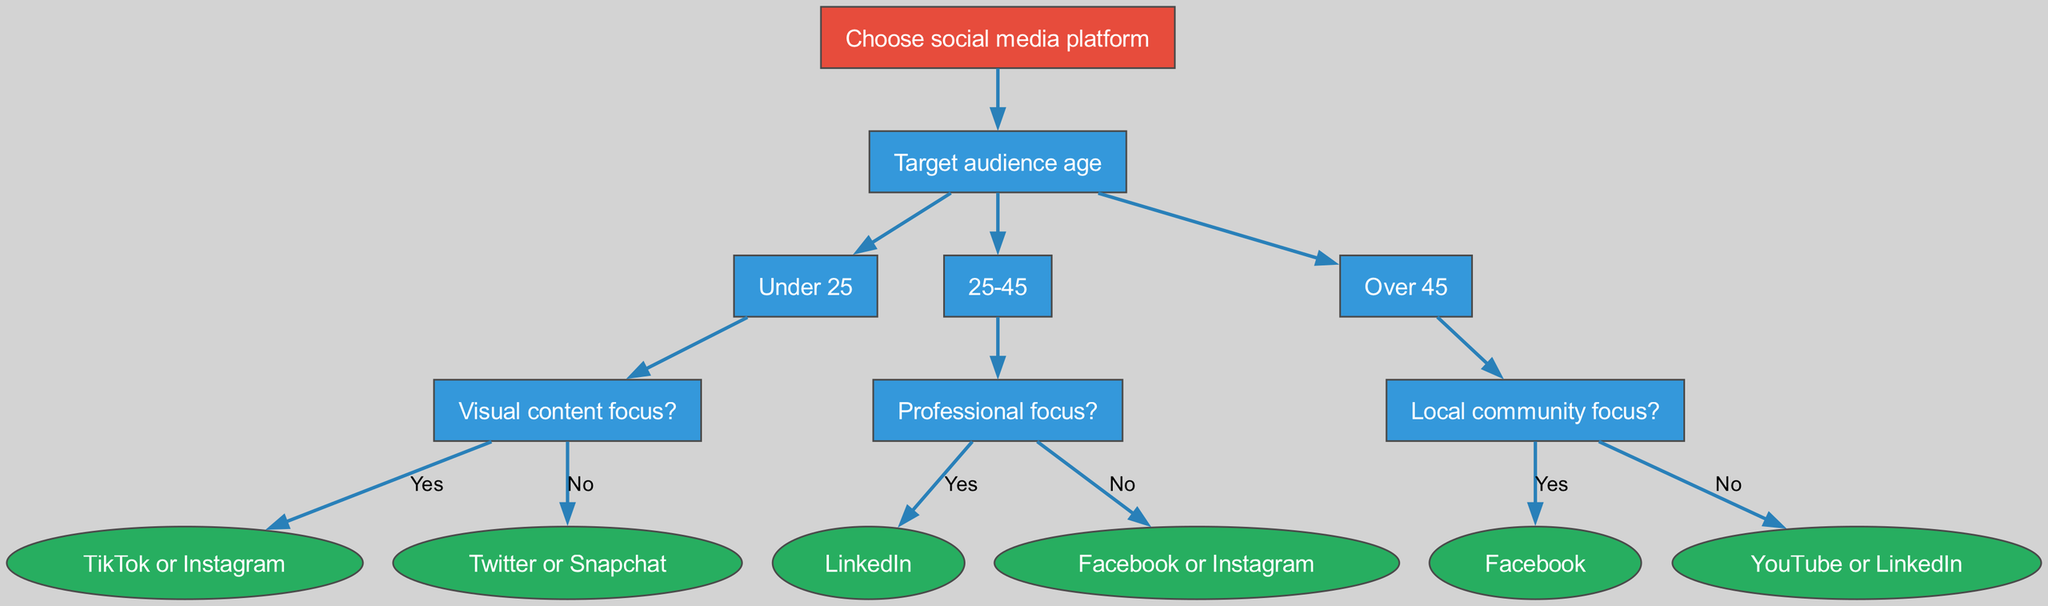What is the root node of the decision tree? The root node is the starting point of the tree and indicates the main decision of choosing a social media platform. In this diagram, the root node is explicitly labeled as "Choose social media platform."
Answer: Choose social media platform How many main age categories are represented in the tree? By analyzing the nodes under the "Target audience age" node, we can count the distinct age categories. There are three categories: "Under 25," "25-45," and "Over 45."
Answer: 3 Which platform is suggested for the age group under 25 if they focus on visual content? To determine the platform, we follow the path from the "Target audience age" node to the "Under 25" node and then to the "Visual content focus?" node. Since the focus is on visual content, the diagram indicates that the output is "TikTok or Instagram."
Answer: TikTok or Instagram If the target audience is 25-45 with a professional focus, what social media platform should be chosen? Starting from the "Target audience age" node, we take the "25-45" path and follow to the "Professional focus?" question. With a "Yes" response, the diagram points to "LinkedIn" as the result.
Answer: LinkedIn What is the result if the focus is on local community for the age group over 45? Following the decision tree, we first identify the age group "Over 45" and then proceed to the "Local community focus?" node. If the answer is "Yes," the result given in the diagram is "Facebook."
Answer: Facebook If the target audience is over 45 and does not focus on local community, which platforms are possible outcomes? We analyze the "Over 45" node and go to the "Local community focus?" question. If the answer is "No," the tree indicates two possible platforms: "YouTube" and "LinkedIn."
Answer: YouTube or LinkedIn What type of content does the age group under 25 prefer according to the tree? The tree indicates a division based on visual content; hence, those under 25 likely prefer visual content types, as indicated by the node "Visual content focus?" connected to this age group.
Answer: Visual content What decision path leads to "Facebook" as the final outcome? To reach "Facebook," we trace the decision tree starting from "Choose social media platform" to "Target audience age," then select "Over 45." Subsequently, we follow "Local community focus?" and choose "Yes," resulting in "Facebook."
Answer: Over 45, Yes How many platforms are suggested for those aged 25-45 without a professional focus? From the node for "25-45," we look at the "Professional focus?" node and see that if the answer is "No," it leads to two platforms mentioned in the diagram: "Facebook or Instagram." Thus, there are two platforms suggested.
Answer: 2 